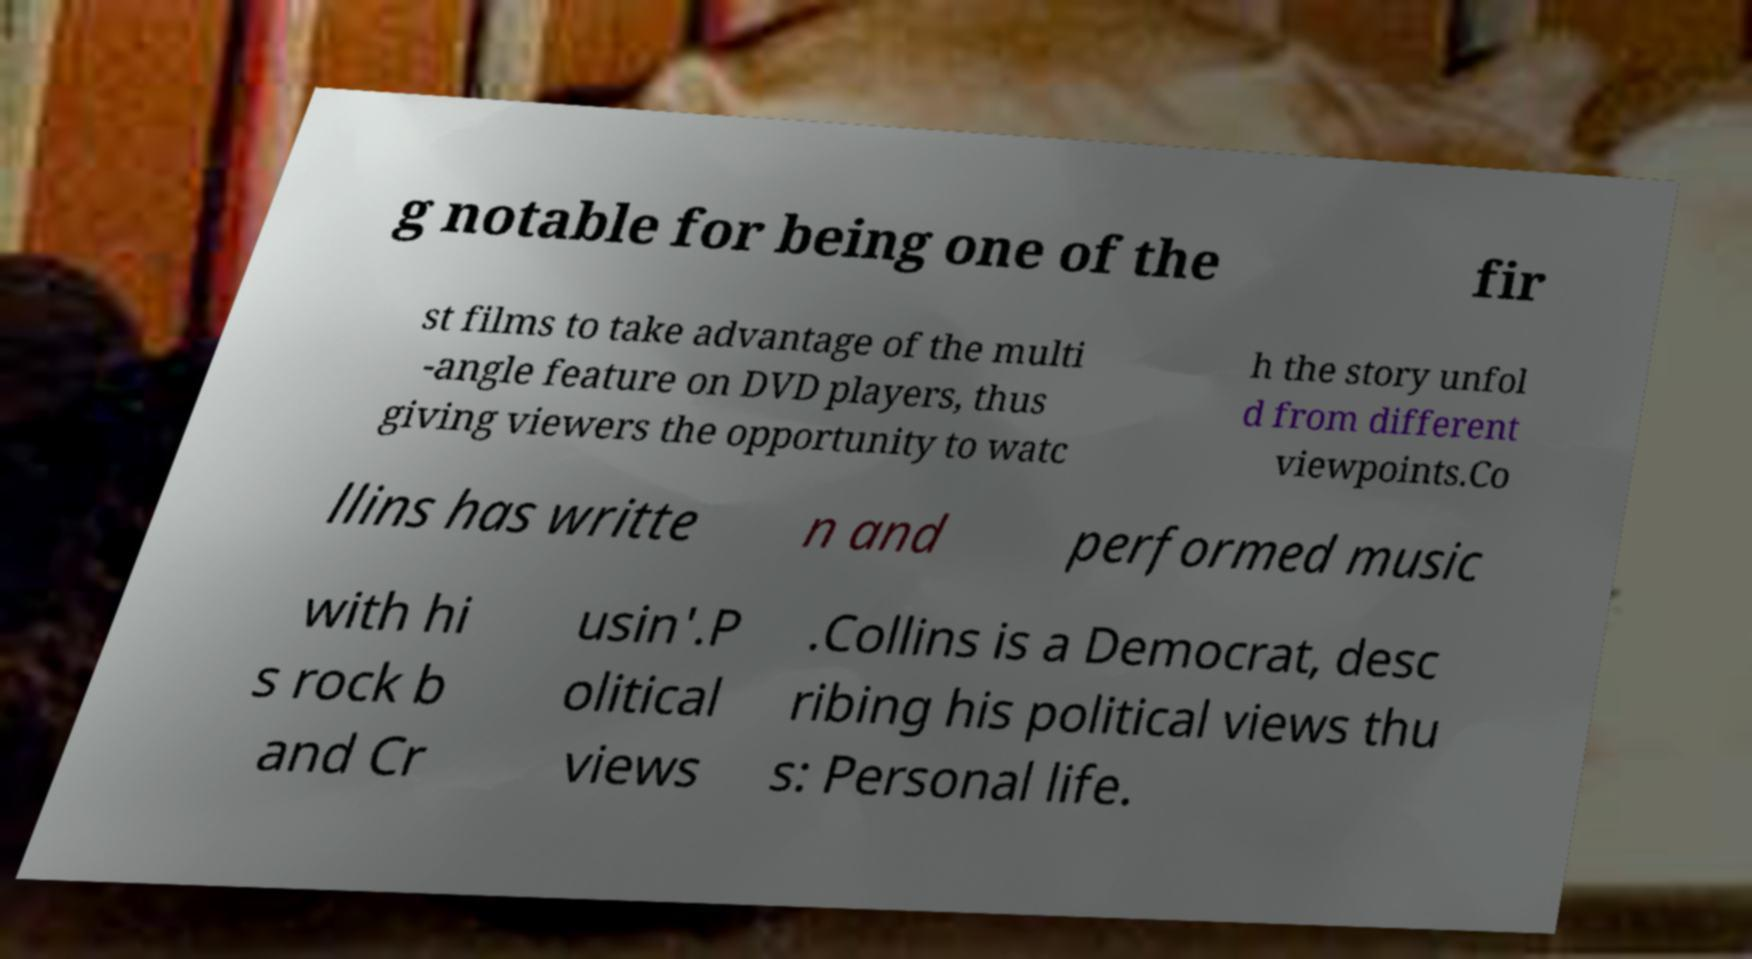Could you extract and type out the text from this image? g notable for being one of the fir st films to take advantage of the multi -angle feature on DVD players, thus giving viewers the opportunity to watc h the story unfol d from different viewpoints.Co llins has writte n and performed music with hi s rock b and Cr usin'.P olitical views .Collins is a Democrat, desc ribing his political views thu s: Personal life. 